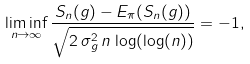<formula> <loc_0><loc_0><loc_500><loc_500>\liminf _ { n \to \infty } \frac { S _ { n } ( g ) - E _ { \pi } ( S _ { n } ( g ) ) } { \sqrt { 2 \, \sigma _ { g } ^ { 2 } \, n \, \log ( \log ( n ) ) } } = - 1 ,</formula> 